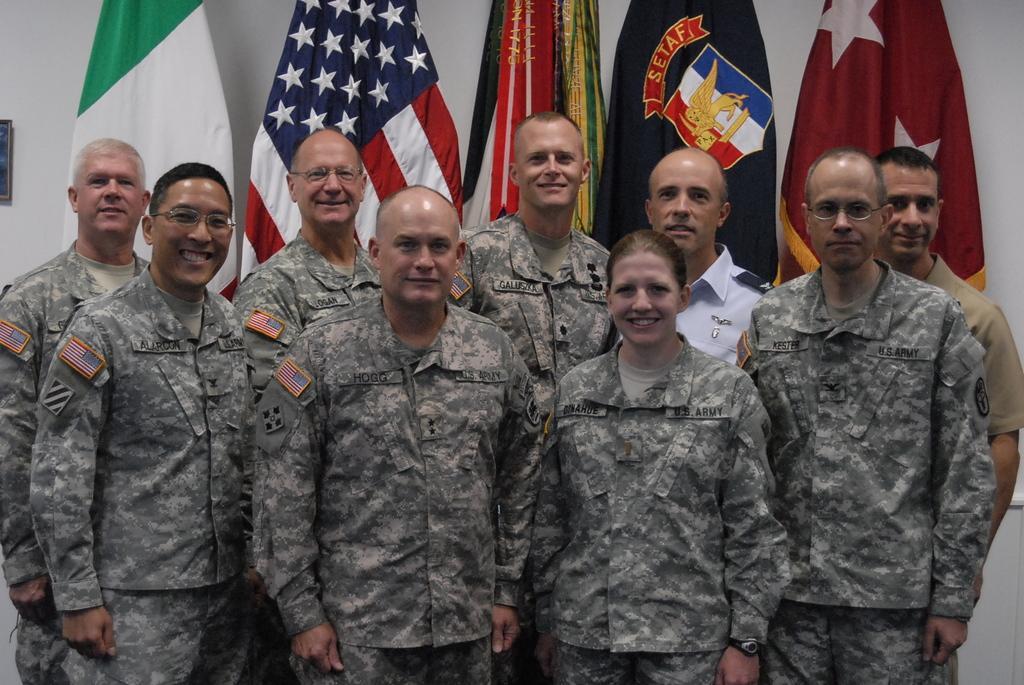Describe this image in one or two sentences. In this image we can see the people wearing the uniform and standing and also smiling. In the background we can see the flags and also a frame attached to the plain wall on the left. 